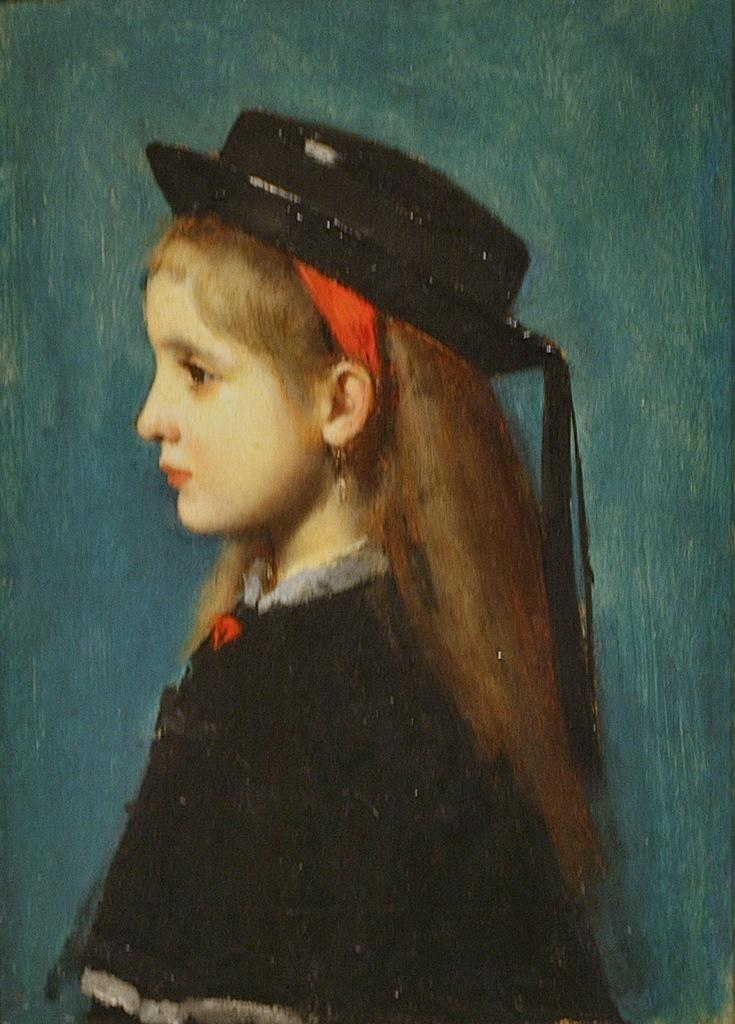Who or what is the main subject in the image? There is a person in the image. What is the person wearing? The person is wearing a black dress and a black cap. What color is the background of the image? The background of the image is green. What type of sand can be seen on the person's shoes in the image? There are no shoes or sand visible in the image; the person is wearing a black dress and cap, and the background is green. 